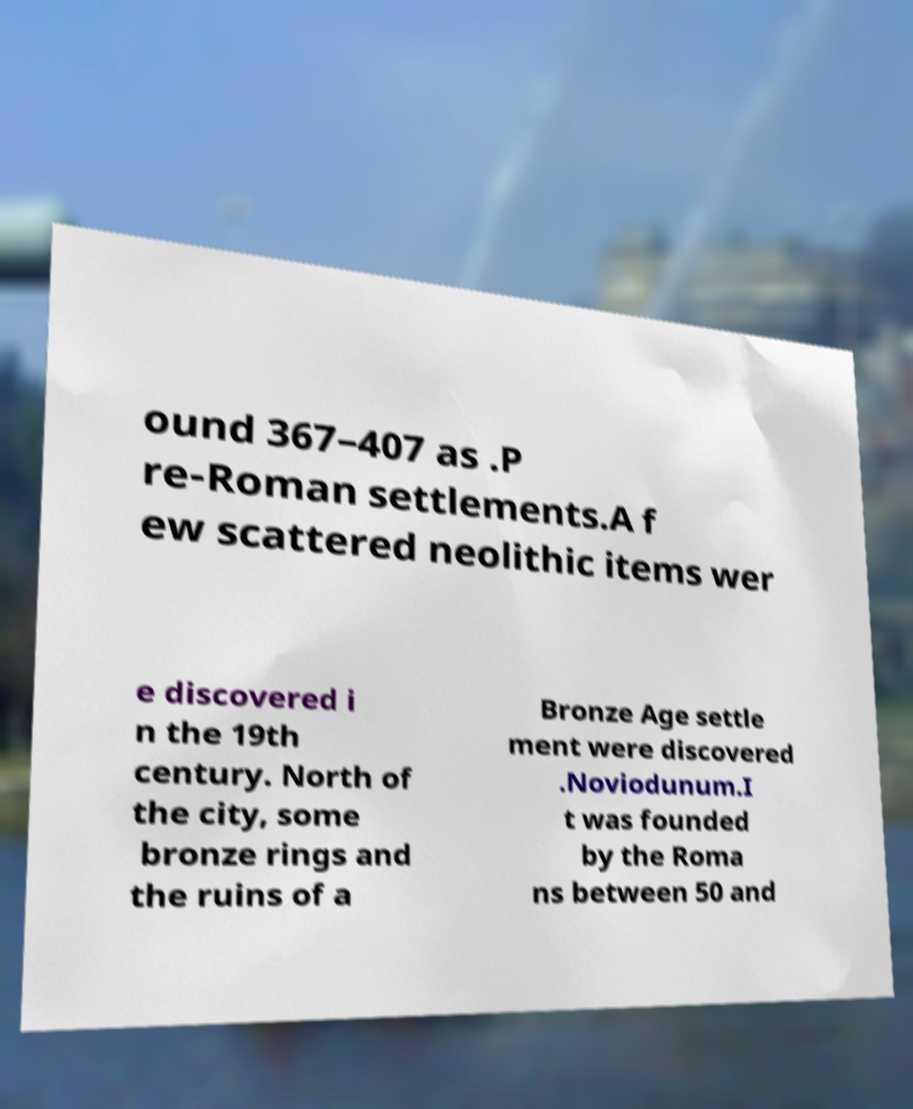Could you extract and type out the text from this image? ound 367–407 as .P re-Roman settlements.A f ew scattered neolithic items wer e discovered i n the 19th century. North of the city, some bronze rings and the ruins of a Bronze Age settle ment were discovered .Noviodunum.I t was founded by the Roma ns between 50 and 